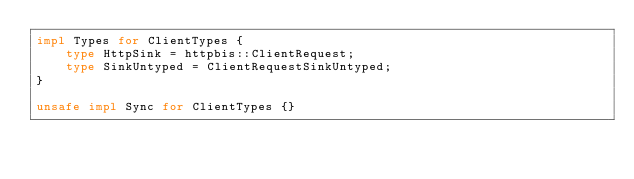Convert code to text. <code><loc_0><loc_0><loc_500><loc_500><_Rust_>impl Types for ClientTypes {
    type HttpSink = httpbis::ClientRequest;
    type SinkUntyped = ClientRequestSinkUntyped;
}

unsafe impl Sync for ClientTypes {}
</code> 